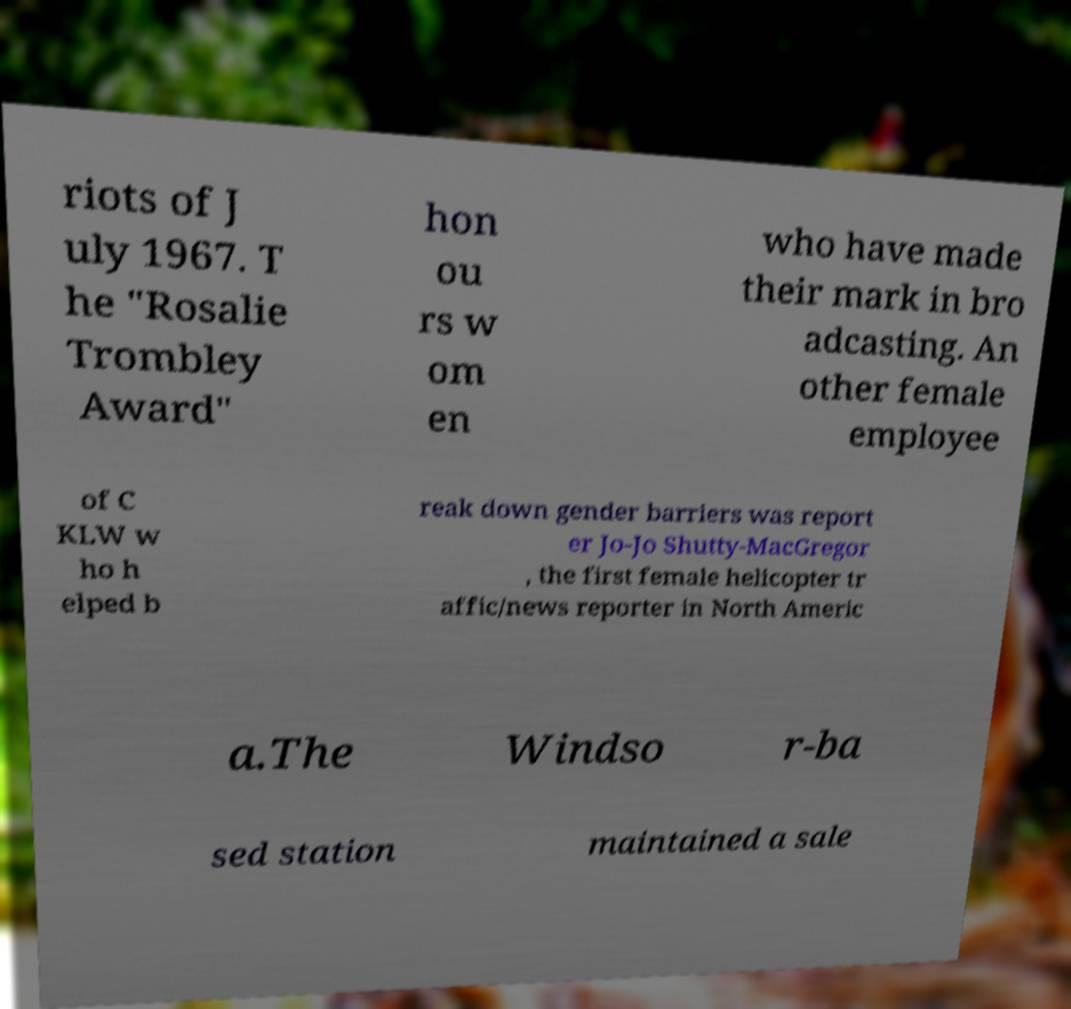What messages or text are displayed in this image? I need them in a readable, typed format. riots of J uly 1967. T he "Rosalie Trombley Award" hon ou rs w om en who have made their mark in bro adcasting. An other female employee of C KLW w ho h elped b reak down gender barriers was report er Jo-Jo Shutty-MacGregor , the first female helicopter tr affic/news reporter in North Americ a.The Windso r-ba sed station maintained a sale 